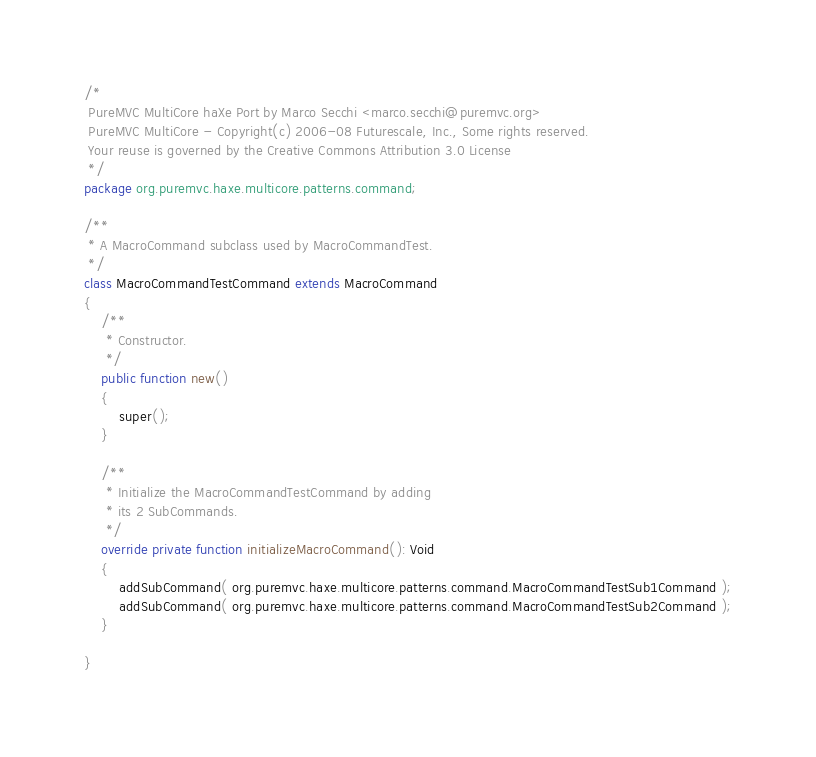Convert code to text. <code><loc_0><loc_0><loc_500><loc_500><_Haxe_>/* 
 PureMVC MultiCore haXe Port by Marco Secchi <marco.secchi@puremvc.org>
 PureMVC MultiCore - Copyright(c) 2006-08 Futurescale, Inc., Some rights reserved. 
 Your reuse is governed by the Creative Commons Attribution 3.0 License 
 */
package org.puremvc.haxe.multicore.patterns.command;

/**
 * A MacroCommand subclass used by MacroCommandTest.
 */
class MacroCommandTestCommand extends MacroCommand
{
	/**
	 * Constructor.
	 */
	public function new()
	{
		super();
	}
		
	/**
	 * Initialize the MacroCommandTestCommand by adding
	 * its 2 SubCommands.
	 */
	override private function initializeMacroCommand(): Void
	{
		addSubCommand( org.puremvc.haxe.multicore.patterns.command.MacroCommandTestSub1Command );
		addSubCommand( org.puremvc.haxe.multicore.patterns.command.MacroCommandTestSub2Command );
	}
	
}</code> 